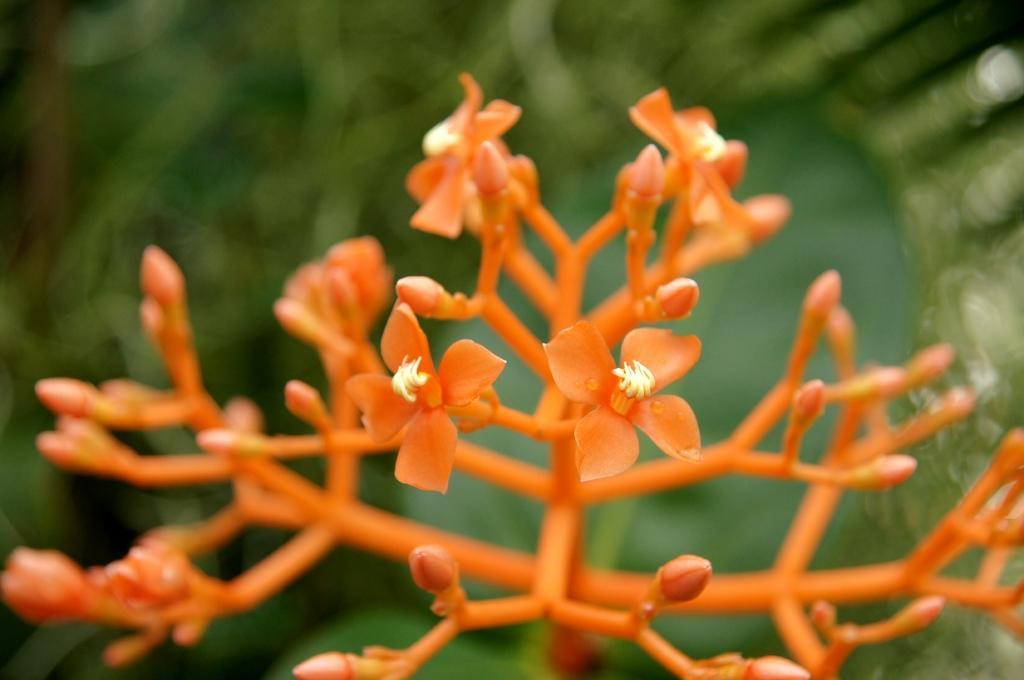Describe this image in one or two sentences. In the picture we can see an orange color plant with orange color flowers and flower buds and behind it, we can see some green color plants which are not clearly visible. 